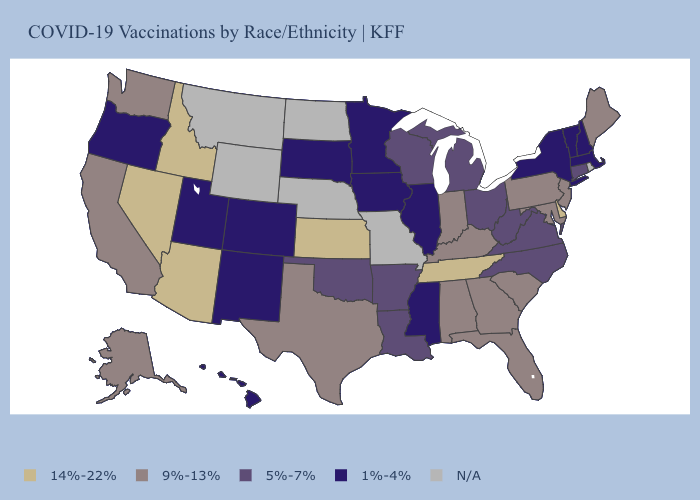What is the value of Wyoming?
Write a very short answer. N/A. Does the map have missing data?
Short answer required. Yes. Which states hav the highest value in the MidWest?
Be succinct. Kansas. What is the highest value in the USA?
Answer briefly. 14%-22%. Name the states that have a value in the range 1%-4%?
Write a very short answer. Colorado, Hawaii, Illinois, Iowa, Massachusetts, Minnesota, Mississippi, New Hampshire, New Mexico, New York, Oregon, South Dakota, Utah, Vermont. Among the states that border Washington , does Idaho have the highest value?
Quick response, please. Yes. What is the highest value in the South ?
Keep it brief. 14%-22%. What is the value of North Carolina?
Give a very brief answer. 5%-7%. Name the states that have a value in the range 14%-22%?
Keep it brief. Arizona, Delaware, Idaho, Kansas, Nevada, Tennessee. What is the value of Arizona?
Answer briefly. 14%-22%. What is the value of Pennsylvania?
Short answer required. 9%-13%. Name the states that have a value in the range 14%-22%?
Answer briefly. Arizona, Delaware, Idaho, Kansas, Nevada, Tennessee. Name the states that have a value in the range 9%-13%?
Quick response, please. Alabama, Alaska, California, Florida, Georgia, Indiana, Kentucky, Maine, Maryland, New Jersey, Pennsylvania, South Carolina, Texas, Washington. What is the value of New Hampshire?
Be succinct. 1%-4%. 